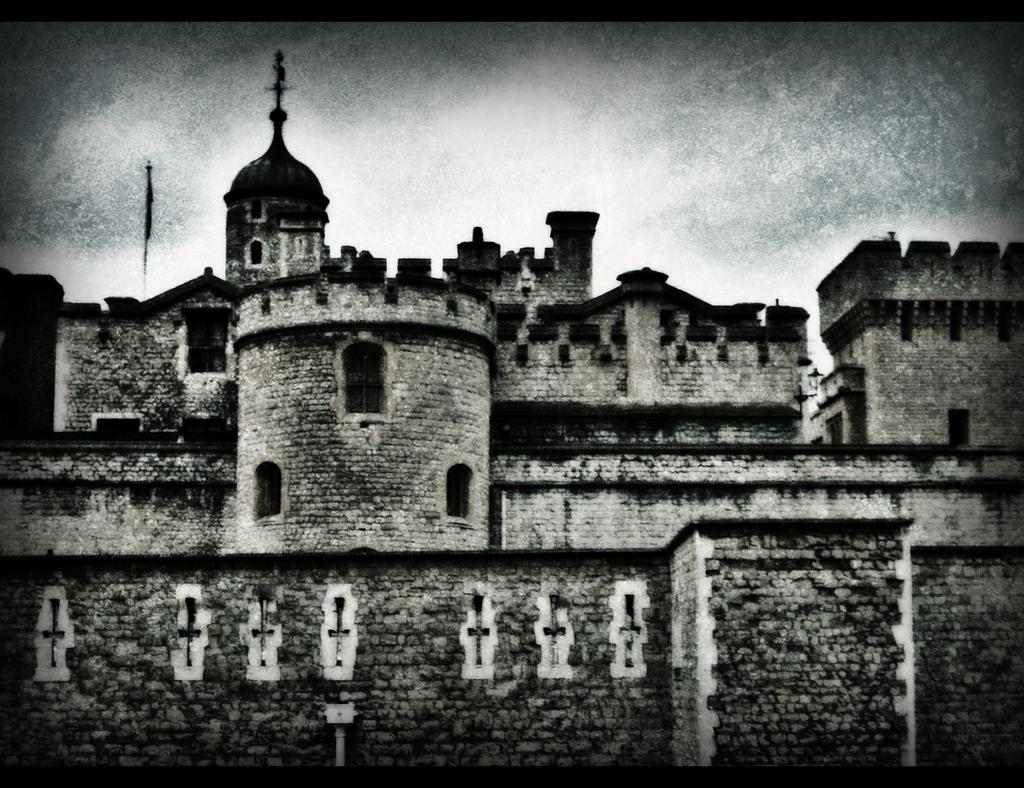What is the main subject of the picture? The main subject of the picture is a monument. What is located on the top of the dome of the monument? There is a cross mark on the top of the dome of the monument. What is positioned beside the cross mark? There is a flag beside the cross mark. What can be seen at the top of the picture? The sky is visible at the top of the picture. Can you tell me how many feathers are attached to the flag in the image? There are no feathers present on the flag in the image. Is there a father figure depicted in the image? There is no father figure depicted in the image; it features a monument with a cross mark and a flag. 